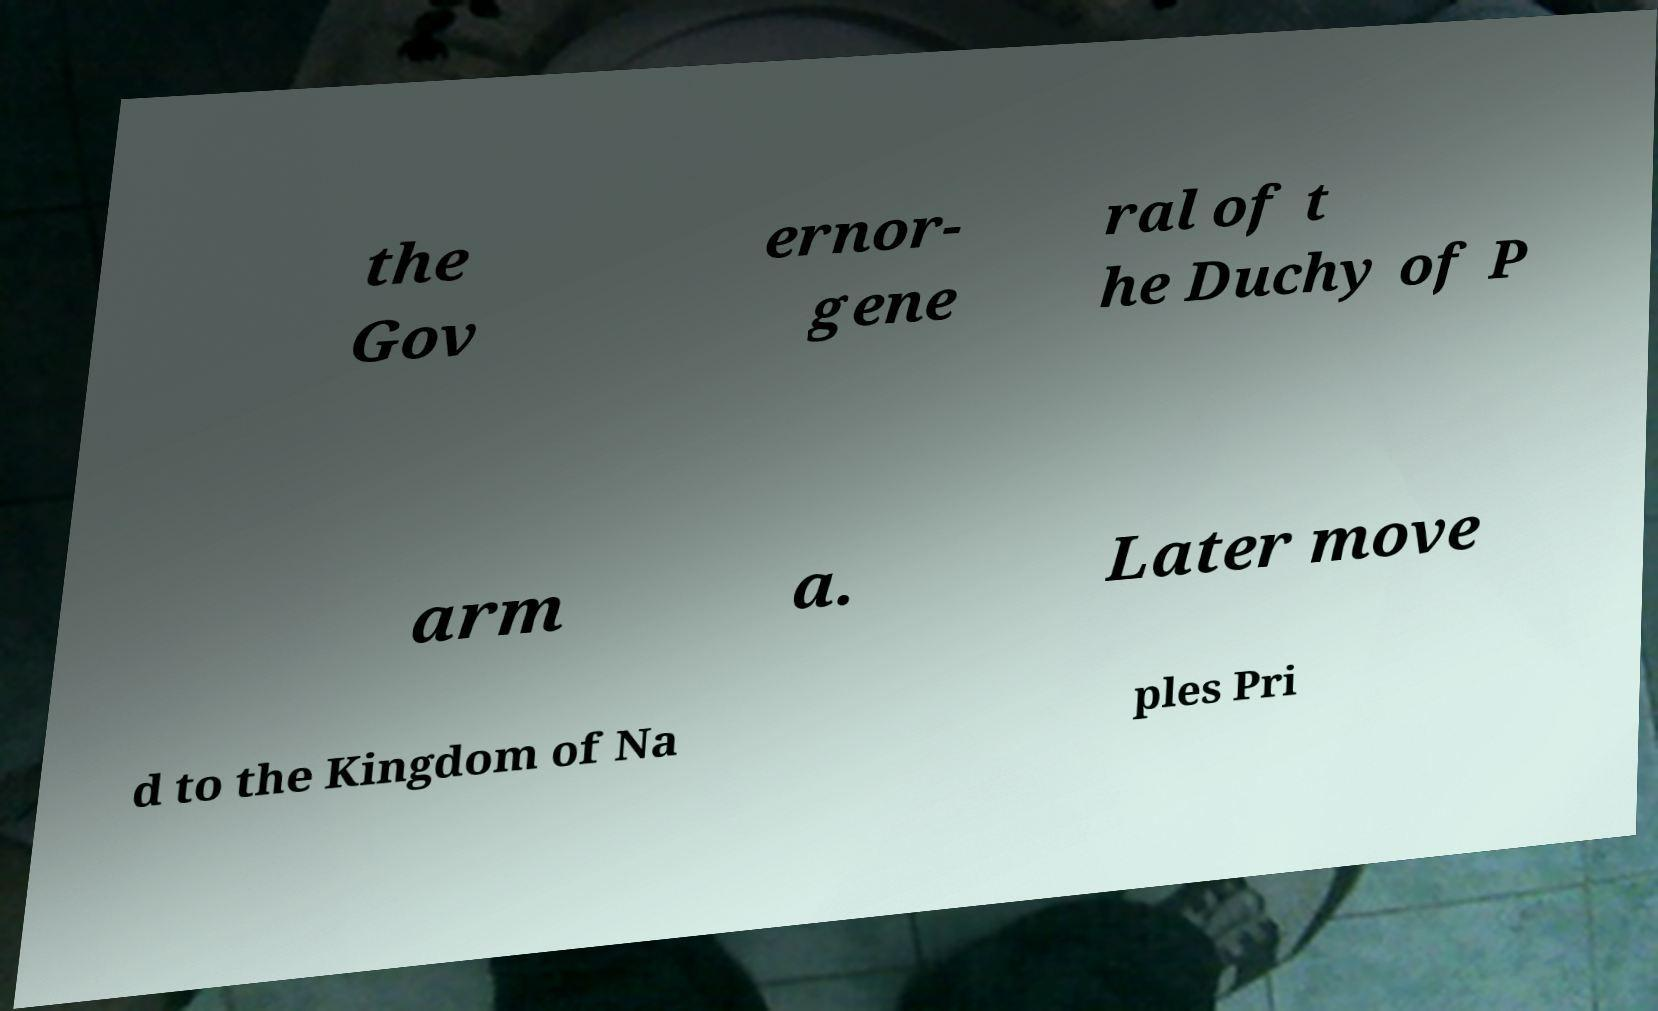Can you accurately transcribe the text from the provided image for me? the Gov ernor- gene ral of t he Duchy of P arm a. Later move d to the Kingdom of Na ples Pri 